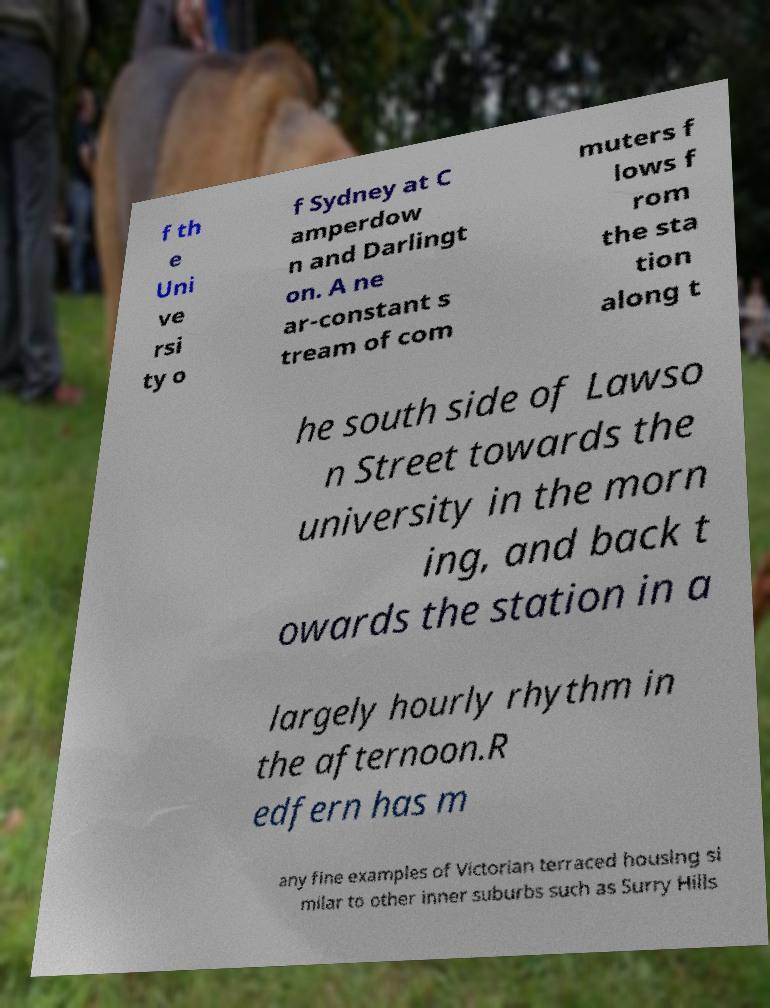For documentation purposes, I need the text within this image transcribed. Could you provide that? f th e Uni ve rsi ty o f Sydney at C amperdow n and Darlingt on. A ne ar-constant s tream of com muters f lows f rom the sta tion along t he south side of Lawso n Street towards the university in the morn ing, and back t owards the station in a largely hourly rhythm in the afternoon.R edfern has m any fine examples of Victorian terraced housing si milar to other inner suburbs such as Surry Hills 